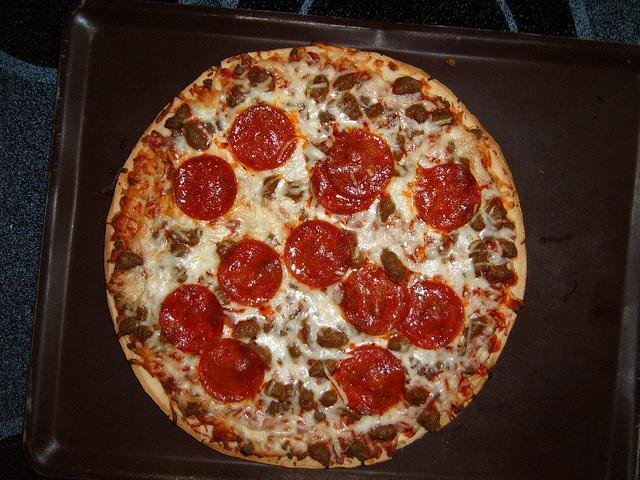How many elephants are in this photo?
Give a very brief answer. 0. 